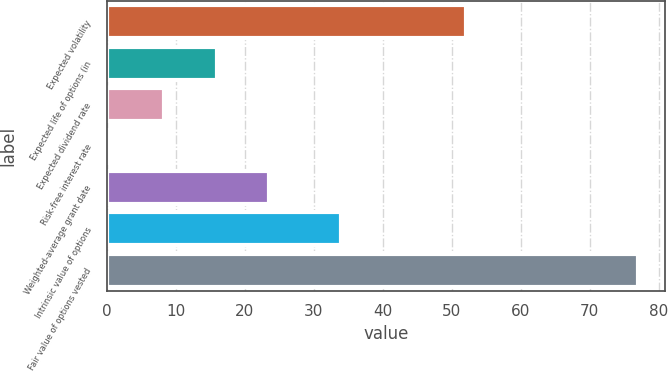Convert chart to OTSL. <chart><loc_0><loc_0><loc_500><loc_500><bar_chart><fcel>Expected volatility<fcel>Expected life of options (in<fcel>Expected dividend rate<fcel>Risk-free interest rate<fcel>Weighted-average grant date<fcel>Intrinsic value of options<fcel>Fair value of options vested<nl><fcel>52<fcel>15.96<fcel>8.33<fcel>0.7<fcel>23.59<fcel>34<fcel>77<nl></chart> 